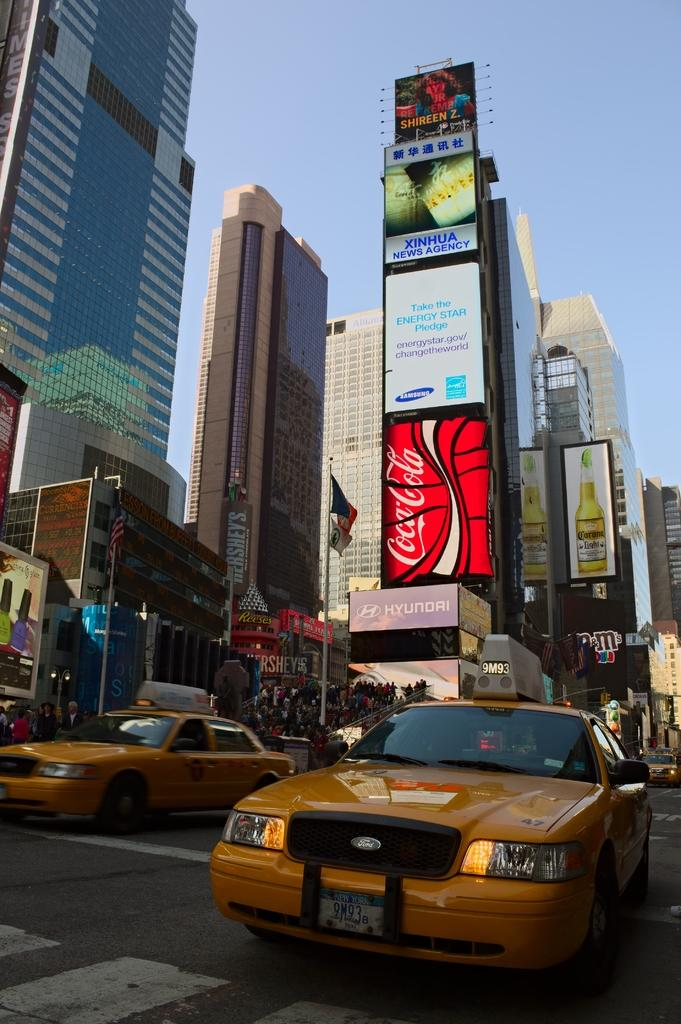<image>
Create a compact narrative representing the image presented. Hyundai is one of several companies advertising on the billboard. 